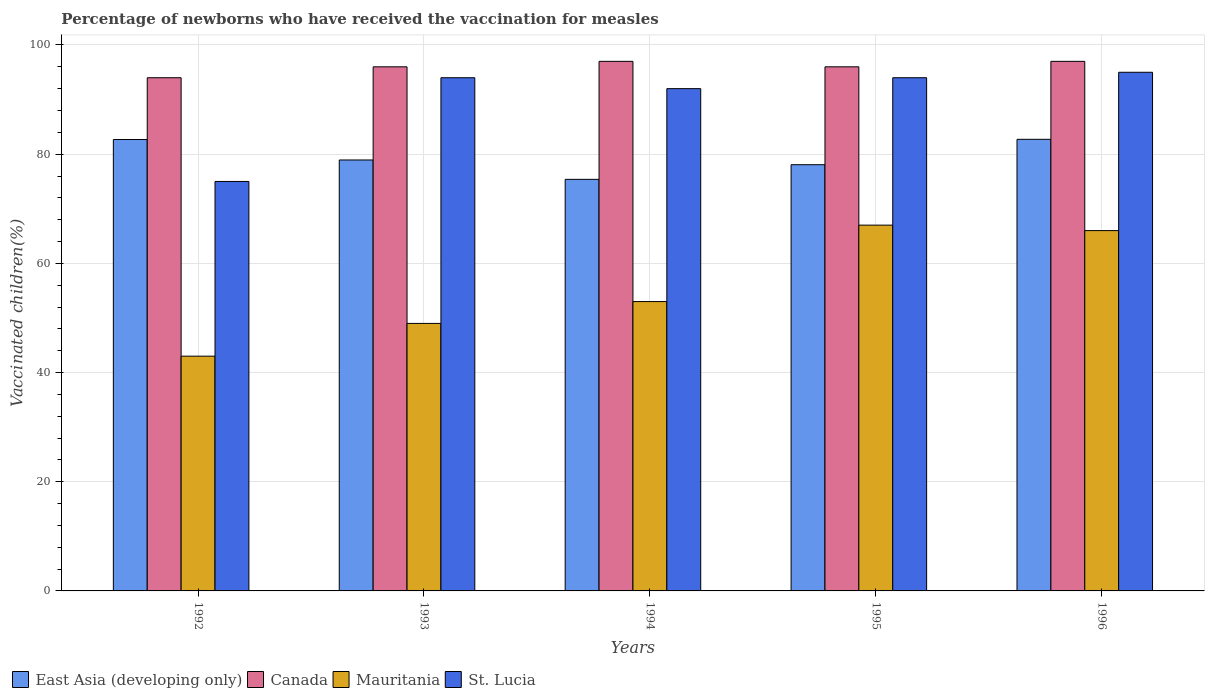How many different coloured bars are there?
Give a very brief answer. 4. Are the number of bars per tick equal to the number of legend labels?
Your answer should be very brief. Yes. How many bars are there on the 3rd tick from the left?
Provide a succinct answer. 4. How many bars are there on the 4th tick from the right?
Offer a terse response. 4. In how many cases, is the number of bars for a given year not equal to the number of legend labels?
Provide a short and direct response. 0. What is the percentage of vaccinated children in Canada in 1994?
Offer a very short reply. 97. Across all years, what is the maximum percentage of vaccinated children in East Asia (developing only)?
Your answer should be very brief. 82.72. In which year was the percentage of vaccinated children in Canada maximum?
Provide a short and direct response. 1994. What is the total percentage of vaccinated children in St. Lucia in the graph?
Offer a very short reply. 450. What is the difference between the percentage of vaccinated children in East Asia (developing only) in 1992 and the percentage of vaccinated children in Canada in 1996?
Provide a short and direct response. -14.31. What is the average percentage of vaccinated children in St. Lucia per year?
Your answer should be compact. 90. What is the ratio of the percentage of vaccinated children in Mauritania in 1992 to that in 1994?
Keep it short and to the point. 0.81. Is the percentage of vaccinated children in East Asia (developing only) in 1994 less than that in 1996?
Offer a terse response. Yes. What is the difference between the highest and the second highest percentage of vaccinated children in Canada?
Make the answer very short. 0. Is the sum of the percentage of vaccinated children in East Asia (developing only) in 1992 and 1994 greater than the maximum percentage of vaccinated children in Canada across all years?
Your answer should be compact. Yes. Is it the case that in every year, the sum of the percentage of vaccinated children in East Asia (developing only) and percentage of vaccinated children in St. Lucia is greater than the sum of percentage of vaccinated children in Canada and percentage of vaccinated children in Mauritania?
Provide a short and direct response. Yes. What does the 4th bar from the left in 1994 represents?
Ensure brevity in your answer.  St. Lucia. What does the 3rd bar from the right in 1992 represents?
Provide a short and direct response. Canada. Is it the case that in every year, the sum of the percentage of vaccinated children in Canada and percentage of vaccinated children in East Asia (developing only) is greater than the percentage of vaccinated children in St. Lucia?
Make the answer very short. Yes. How many bars are there?
Provide a short and direct response. 20. Are all the bars in the graph horizontal?
Keep it short and to the point. No. Are the values on the major ticks of Y-axis written in scientific E-notation?
Offer a very short reply. No. Does the graph contain any zero values?
Provide a succinct answer. No. Where does the legend appear in the graph?
Provide a succinct answer. Bottom left. How many legend labels are there?
Give a very brief answer. 4. What is the title of the graph?
Give a very brief answer. Percentage of newborns who have received the vaccination for measles. Does "Lesotho" appear as one of the legend labels in the graph?
Your answer should be compact. No. What is the label or title of the X-axis?
Your answer should be compact. Years. What is the label or title of the Y-axis?
Make the answer very short. Vaccinated children(%). What is the Vaccinated children(%) of East Asia (developing only) in 1992?
Your response must be concise. 82.69. What is the Vaccinated children(%) of Canada in 1992?
Ensure brevity in your answer.  94. What is the Vaccinated children(%) of Mauritania in 1992?
Offer a terse response. 43. What is the Vaccinated children(%) in East Asia (developing only) in 1993?
Offer a terse response. 78.94. What is the Vaccinated children(%) in Canada in 1993?
Offer a terse response. 96. What is the Vaccinated children(%) of Mauritania in 1993?
Provide a succinct answer. 49. What is the Vaccinated children(%) of St. Lucia in 1993?
Provide a short and direct response. 94. What is the Vaccinated children(%) in East Asia (developing only) in 1994?
Your answer should be very brief. 75.39. What is the Vaccinated children(%) of Canada in 1994?
Provide a short and direct response. 97. What is the Vaccinated children(%) in Mauritania in 1994?
Offer a very short reply. 53. What is the Vaccinated children(%) of St. Lucia in 1994?
Keep it short and to the point. 92. What is the Vaccinated children(%) in East Asia (developing only) in 1995?
Make the answer very short. 78.07. What is the Vaccinated children(%) in Canada in 1995?
Provide a short and direct response. 96. What is the Vaccinated children(%) of St. Lucia in 1995?
Your response must be concise. 94. What is the Vaccinated children(%) of East Asia (developing only) in 1996?
Offer a very short reply. 82.72. What is the Vaccinated children(%) of Canada in 1996?
Offer a terse response. 97. What is the Vaccinated children(%) in Mauritania in 1996?
Offer a terse response. 66. Across all years, what is the maximum Vaccinated children(%) of East Asia (developing only)?
Provide a succinct answer. 82.72. Across all years, what is the maximum Vaccinated children(%) in Canada?
Offer a terse response. 97. Across all years, what is the maximum Vaccinated children(%) in Mauritania?
Offer a very short reply. 67. Across all years, what is the minimum Vaccinated children(%) in East Asia (developing only)?
Make the answer very short. 75.39. Across all years, what is the minimum Vaccinated children(%) of Canada?
Your answer should be very brief. 94. Across all years, what is the minimum Vaccinated children(%) in St. Lucia?
Your response must be concise. 75. What is the total Vaccinated children(%) in East Asia (developing only) in the graph?
Your answer should be very brief. 397.8. What is the total Vaccinated children(%) in Canada in the graph?
Give a very brief answer. 480. What is the total Vaccinated children(%) of Mauritania in the graph?
Offer a terse response. 278. What is the total Vaccinated children(%) in St. Lucia in the graph?
Offer a very short reply. 450. What is the difference between the Vaccinated children(%) in East Asia (developing only) in 1992 and that in 1993?
Ensure brevity in your answer.  3.75. What is the difference between the Vaccinated children(%) of St. Lucia in 1992 and that in 1993?
Ensure brevity in your answer.  -19. What is the difference between the Vaccinated children(%) of East Asia (developing only) in 1992 and that in 1994?
Ensure brevity in your answer.  7.3. What is the difference between the Vaccinated children(%) of Canada in 1992 and that in 1994?
Offer a terse response. -3. What is the difference between the Vaccinated children(%) of Mauritania in 1992 and that in 1994?
Ensure brevity in your answer.  -10. What is the difference between the Vaccinated children(%) of St. Lucia in 1992 and that in 1994?
Provide a short and direct response. -17. What is the difference between the Vaccinated children(%) of East Asia (developing only) in 1992 and that in 1995?
Your response must be concise. 4.62. What is the difference between the Vaccinated children(%) of Canada in 1992 and that in 1995?
Your response must be concise. -2. What is the difference between the Vaccinated children(%) of St. Lucia in 1992 and that in 1995?
Provide a succinct answer. -19. What is the difference between the Vaccinated children(%) in East Asia (developing only) in 1992 and that in 1996?
Offer a very short reply. -0.03. What is the difference between the Vaccinated children(%) of Canada in 1992 and that in 1996?
Give a very brief answer. -3. What is the difference between the Vaccinated children(%) of Mauritania in 1992 and that in 1996?
Provide a short and direct response. -23. What is the difference between the Vaccinated children(%) of East Asia (developing only) in 1993 and that in 1994?
Your answer should be very brief. 3.55. What is the difference between the Vaccinated children(%) in Canada in 1993 and that in 1994?
Keep it short and to the point. -1. What is the difference between the Vaccinated children(%) in East Asia (developing only) in 1993 and that in 1995?
Provide a short and direct response. 0.87. What is the difference between the Vaccinated children(%) of St. Lucia in 1993 and that in 1995?
Provide a short and direct response. 0. What is the difference between the Vaccinated children(%) in East Asia (developing only) in 1993 and that in 1996?
Your response must be concise. -3.78. What is the difference between the Vaccinated children(%) in St. Lucia in 1993 and that in 1996?
Your answer should be compact. -1. What is the difference between the Vaccinated children(%) of East Asia (developing only) in 1994 and that in 1995?
Ensure brevity in your answer.  -2.68. What is the difference between the Vaccinated children(%) of Canada in 1994 and that in 1995?
Ensure brevity in your answer.  1. What is the difference between the Vaccinated children(%) of St. Lucia in 1994 and that in 1995?
Provide a short and direct response. -2. What is the difference between the Vaccinated children(%) of East Asia (developing only) in 1994 and that in 1996?
Offer a terse response. -7.33. What is the difference between the Vaccinated children(%) in Mauritania in 1994 and that in 1996?
Make the answer very short. -13. What is the difference between the Vaccinated children(%) in St. Lucia in 1994 and that in 1996?
Ensure brevity in your answer.  -3. What is the difference between the Vaccinated children(%) in East Asia (developing only) in 1995 and that in 1996?
Give a very brief answer. -4.65. What is the difference between the Vaccinated children(%) of Mauritania in 1995 and that in 1996?
Give a very brief answer. 1. What is the difference between the Vaccinated children(%) in St. Lucia in 1995 and that in 1996?
Give a very brief answer. -1. What is the difference between the Vaccinated children(%) of East Asia (developing only) in 1992 and the Vaccinated children(%) of Canada in 1993?
Offer a very short reply. -13.31. What is the difference between the Vaccinated children(%) in East Asia (developing only) in 1992 and the Vaccinated children(%) in Mauritania in 1993?
Offer a very short reply. 33.69. What is the difference between the Vaccinated children(%) of East Asia (developing only) in 1992 and the Vaccinated children(%) of St. Lucia in 1993?
Provide a succinct answer. -11.31. What is the difference between the Vaccinated children(%) of Mauritania in 1992 and the Vaccinated children(%) of St. Lucia in 1993?
Offer a very short reply. -51. What is the difference between the Vaccinated children(%) in East Asia (developing only) in 1992 and the Vaccinated children(%) in Canada in 1994?
Provide a succinct answer. -14.31. What is the difference between the Vaccinated children(%) in East Asia (developing only) in 1992 and the Vaccinated children(%) in Mauritania in 1994?
Your answer should be very brief. 29.69. What is the difference between the Vaccinated children(%) in East Asia (developing only) in 1992 and the Vaccinated children(%) in St. Lucia in 1994?
Offer a terse response. -9.31. What is the difference between the Vaccinated children(%) in Canada in 1992 and the Vaccinated children(%) in Mauritania in 1994?
Make the answer very short. 41. What is the difference between the Vaccinated children(%) in Mauritania in 1992 and the Vaccinated children(%) in St. Lucia in 1994?
Your response must be concise. -49. What is the difference between the Vaccinated children(%) in East Asia (developing only) in 1992 and the Vaccinated children(%) in Canada in 1995?
Provide a succinct answer. -13.31. What is the difference between the Vaccinated children(%) in East Asia (developing only) in 1992 and the Vaccinated children(%) in Mauritania in 1995?
Provide a succinct answer. 15.69. What is the difference between the Vaccinated children(%) of East Asia (developing only) in 1992 and the Vaccinated children(%) of St. Lucia in 1995?
Your answer should be very brief. -11.31. What is the difference between the Vaccinated children(%) in Canada in 1992 and the Vaccinated children(%) in Mauritania in 1995?
Provide a succinct answer. 27. What is the difference between the Vaccinated children(%) of Canada in 1992 and the Vaccinated children(%) of St. Lucia in 1995?
Give a very brief answer. 0. What is the difference between the Vaccinated children(%) of Mauritania in 1992 and the Vaccinated children(%) of St. Lucia in 1995?
Your answer should be compact. -51. What is the difference between the Vaccinated children(%) of East Asia (developing only) in 1992 and the Vaccinated children(%) of Canada in 1996?
Offer a terse response. -14.31. What is the difference between the Vaccinated children(%) of East Asia (developing only) in 1992 and the Vaccinated children(%) of Mauritania in 1996?
Offer a very short reply. 16.69. What is the difference between the Vaccinated children(%) in East Asia (developing only) in 1992 and the Vaccinated children(%) in St. Lucia in 1996?
Provide a succinct answer. -12.31. What is the difference between the Vaccinated children(%) in Mauritania in 1992 and the Vaccinated children(%) in St. Lucia in 1996?
Provide a succinct answer. -52. What is the difference between the Vaccinated children(%) in East Asia (developing only) in 1993 and the Vaccinated children(%) in Canada in 1994?
Provide a succinct answer. -18.06. What is the difference between the Vaccinated children(%) of East Asia (developing only) in 1993 and the Vaccinated children(%) of Mauritania in 1994?
Offer a terse response. 25.94. What is the difference between the Vaccinated children(%) of East Asia (developing only) in 1993 and the Vaccinated children(%) of St. Lucia in 1994?
Your response must be concise. -13.06. What is the difference between the Vaccinated children(%) of Mauritania in 1993 and the Vaccinated children(%) of St. Lucia in 1994?
Your answer should be very brief. -43. What is the difference between the Vaccinated children(%) of East Asia (developing only) in 1993 and the Vaccinated children(%) of Canada in 1995?
Give a very brief answer. -17.06. What is the difference between the Vaccinated children(%) in East Asia (developing only) in 1993 and the Vaccinated children(%) in Mauritania in 1995?
Keep it short and to the point. 11.94. What is the difference between the Vaccinated children(%) of East Asia (developing only) in 1993 and the Vaccinated children(%) of St. Lucia in 1995?
Keep it short and to the point. -15.06. What is the difference between the Vaccinated children(%) of Canada in 1993 and the Vaccinated children(%) of Mauritania in 1995?
Your response must be concise. 29. What is the difference between the Vaccinated children(%) in Canada in 1993 and the Vaccinated children(%) in St. Lucia in 1995?
Offer a terse response. 2. What is the difference between the Vaccinated children(%) of Mauritania in 1993 and the Vaccinated children(%) of St. Lucia in 1995?
Keep it short and to the point. -45. What is the difference between the Vaccinated children(%) in East Asia (developing only) in 1993 and the Vaccinated children(%) in Canada in 1996?
Provide a succinct answer. -18.06. What is the difference between the Vaccinated children(%) in East Asia (developing only) in 1993 and the Vaccinated children(%) in Mauritania in 1996?
Your answer should be very brief. 12.94. What is the difference between the Vaccinated children(%) of East Asia (developing only) in 1993 and the Vaccinated children(%) of St. Lucia in 1996?
Keep it short and to the point. -16.06. What is the difference between the Vaccinated children(%) of Canada in 1993 and the Vaccinated children(%) of St. Lucia in 1996?
Your response must be concise. 1. What is the difference between the Vaccinated children(%) of Mauritania in 1993 and the Vaccinated children(%) of St. Lucia in 1996?
Offer a very short reply. -46. What is the difference between the Vaccinated children(%) of East Asia (developing only) in 1994 and the Vaccinated children(%) of Canada in 1995?
Provide a succinct answer. -20.61. What is the difference between the Vaccinated children(%) of East Asia (developing only) in 1994 and the Vaccinated children(%) of Mauritania in 1995?
Give a very brief answer. 8.39. What is the difference between the Vaccinated children(%) in East Asia (developing only) in 1994 and the Vaccinated children(%) in St. Lucia in 1995?
Make the answer very short. -18.61. What is the difference between the Vaccinated children(%) in Canada in 1994 and the Vaccinated children(%) in St. Lucia in 1995?
Your response must be concise. 3. What is the difference between the Vaccinated children(%) in Mauritania in 1994 and the Vaccinated children(%) in St. Lucia in 1995?
Ensure brevity in your answer.  -41. What is the difference between the Vaccinated children(%) in East Asia (developing only) in 1994 and the Vaccinated children(%) in Canada in 1996?
Make the answer very short. -21.61. What is the difference between the Vaccinated children(%) of East Asia (developing only) in 1994 and the Vaccinated children(%) of Mauritania in 1996?
Offer a very short reply. 9.39. What is the difference between the Vaccinated children(%) of East Asia (developing only) in 1994 and the Vaccinated children(%) of St. Lucia in 1996?
Give a very brief answer. -19.61. What is the difference between the Vaccinated children(%) of Canada in 1994 and the Vaccinated children(%) of St. Lucia in 1996?
Your answer should be compact. 2. What is the difference between the Vaccinated children(%) in Mauritania in 1994 and the Vaccinated children(%) in St. Lucia in 1996?
Offer a very short reply. -42. What is the difference between the Vaccinated children(%) in East Asia (developing only) in 1995 and the Vaccinated children(%) in Canada in 1996?
Your answer should be compact. -18.93. What is the difference between the Vaccinated children(%) in East Asia (developing only) in 1995 and the Vaccinated children(%) in Mauritania in 1996?
Ensure brevity in your answer.  12.07. What is the difference between the Vaccinated children(%) of East Asia (developing only) in 1995 and the Vaccinated children(%) of St. Lucia in 1996?
Provide a short and direct response. -16.93. What is the difference between the Vaccinated children(%) of Canada in 1995 and the Vaccinated children(%) of St. Lucia in 1996?
Your answer should be very brief. 1. What is the difference between the Vaccinated children(%) in Mauritania in 1995 and the Vaccinated children(%) in St. Lucia in 1996?
Ensure brevity in your answer.  -28. What is the average Vaccinated children(%) in East Asia (developing only) per year?
Give a very brief answer. 79.56. What is the average Vaccinated children(%) of Canada per year?
Your response must be concise. 96. What is the average Vaccinated children(%) of Mauritania per year?
Your answer should be compact. 55.6. In the year 1992, what is the difference between the Vaccinated children(%) in East Asia (developing only) and Vaccinated children(%) in Canada?
Provide a succinct answer. -11.31. In the year 1992, what is the difference between the Vaccinated children(%) of East Asia (developing only) and Vaccinated children(%) of Mauritania?
Provide a succinct answer. 39.69. In the year 1992, what is the difference between the Vaccinated children(%) in East Asia (developing only) and Vaccinated children(%) in St. Lucia?
Provide a short and direct response. 7.69. In the year 1992, what is the difference between the Vaccinated children(%) in Mauritania and Vaccinated children(%) in St. Lucia?
Your response must be concise. -32. In the year 1993, what is the difference between the Vaccinated children(%) of East Asia (developing only) and Vaccinated children(%) of Canada?
Make the answer very short. -17.06. In the year 1993, what is the difference between the Vaccinated children(%) of East Asia (developing only) and Vaccinated children(%) of Mauritania?
Offer a terse response. 29.94. In the year 1993, what is the difference between the Vaccinated children(%) of East Asia (developing only) and Vaccinated children(%) of St. Lucia?
Ensure brevity in your answer.  -15.06. In the year 1993, what is the difference between the Vaccinated children(%) of Canada and Vaccinated children(%) of Mauritania?
Your answer should be compact. 47. In the year 1993, what is the difference between the Vaccinated children(%) of Canada and Vaccinated children(%) of St. Lucia?
Your answer should be compact. 2. In the year 1993, what is the difference between the Vaccinated children(%) of Mauritania and Vaccinated children(%) of St. Lucia?
Your response must be concise. -45. In the year 1994, what is the difference between the Vaccinated children(%) in East Asia (developing only) and Vaccinated children(%) in Canada?
Provide a succinct answer. -21.61. In the year 1994, what is the difference between the Vaccinated children(%) in East Asia (developing only) and Vaccinated children(%) in Mauritania?
Make the answer very short. 22.39. In the year 1994, what is the difference between the Vaccinated children(%) of East Asia (developing only) and Vaccinated children(%) of St. Lucia?
Make the answer very short. -16.61. In the year 1994, what is the difference between the Vaccinated children(%) in Canada and Vaccinated children(%) in Mauritania?
Offer a very short reply. 44. In the year 1994, what is the difference between the Vaccinated children(%) of Mauritania and Vaccinated children(%) of St. Lucia?
Make the answer very short. -39. In the year 1995, what is the difference between the Vaccinated children(%) of East Asia (developing only) and Vaccinated children(%) of Canada?
Give a very brief answer. -17.93. In the year 1995, what is the difference between the Vaccinated children(%) of East Asia (developing only) and Vaccinated children(%) of Mauritania?
Your answer should be compact. 11.07. In the year 1995, what is the difference between the Vaccinated children(%) of East Asia (developing only) and Vaccinated children(%) of St. Lucia?
Offer a very short reply. -15.93. In the year 1995, what is the difference between the Vaccinated children(%) of Canada and Vaccinated children(%) of Mauritania?
Ensure brevity in your answer.  29. In the year 1995, what is the difference between the Vaccinated children(%) of Canada and Vaccinated children(%) of St. Lucia?
Ensure brevity in your answer.  2. In the year 1995, what is the difference between the Vaccinated children(%) in Mauritania and Vaccinated children(%) in St. Lucia?
Give a very brief answer. -27. In the year 1996, what is the difference between the Vaccinated children(%) in East Asia (developing only) and Vaccinated children(%) in Canada?
Provide a short and direct response. -14.28. In the year 1996, what is the difference between the Vaccinated children(%) in East Asia (developing only) and Vaccinated children(%) in Mauritania?
Ensure brevity in your answer.  16.72. In the year 1996, what is the difference between the Vaccinated children(%) in East Asia (developing only) and Vaccinated children(%) in St. Lucia?
Your response must be concise. -12.28. In the year 1996, what is the difference between the Vaccinated children(%) of Canada and Vaccinated children(%) of Mauritania?
Your answer should be compact. 31. In the year 1996, what is the difference between the Vaccinated children(%) in Canada and Vaccinated children(%) in St. Lucia?
Your answer should be very brief. 2. In the year 1996, what is the difference between the Vaccinated children(%) of Mauritania and Vaccinated children(%) of St. Lucia?
Make the answer very short. -29. What is the ratio of the Vaccinated children(%) of East Asia (developing only) in 1992 to that in 1993?
Provide a succinct answer. 1.05. What is the ratio of the Vaccinated children(%) of Canada in 1992 to that in 1993?
Make the answer very short. 0.98. What is the ratio of the Vaccinated children(%) of Mauritania in 1992 to that in 1993?
Your answer should be compact. 0.88. What is the ratio of the Vaccinated children(%) in St. Lucia in 1992 to that in 1993?
Give a very brief answer. 0.8. What is the ratio of the Vaccinated children(%) in East Asia (developing only) in 1992 to that in 1994?
Give a very brief answer. 1.1. What is the ratio of the Vaccinated children(%) of Canada in 1992 to that in 1994?
Offer a terse response. 0.97. What is the ratio of the Vaccinated children(%) in Mauritania in 1992 to that in 1994?
Your answer should be very brief. 0.81. What is the ratio of the Vaccinated children(%) of St. Lucia in 1992 to that in 1994?
Offer a terse response. 0.82. What is the ratio of the Vaccinated children(%) of East Asia (developing only) in 1992 to that in 1995?
Give a very brief answer. 1.06. What is the ratio of the Vaccinated children(%) of Canada in 1992 to that in 1995?
Keep it short and to the point. 0.98. What is the ratio of the Vaccinated children(%) of Mauritania in 1992 to that in 1995?
Provide a succinct answer. 0.64. What is the ratio of the Vaccinated children(%) of St. Lucia in 1992 to that in 1995?
Give a very brief answer. 0.8. What is the ratio of the Vaccinated children(%) in Canada in 1992 to that in 1996?
Your answer should be compact. 0.97. What is the ratio of the Vaccinated children(%) of Mauritania in 1992 to that in 1996?
Ensure brevity in your answer.  0.65. What is the ratio of the Vaccinated children(%) of St. Lucia in 1992 to that in 1996?
Provide a succinct answer. 0.79. What is the ratio of the Vaccinated children(%) in East Asia (developing only) in 1993 to that in 1994?
Make the answer very short. 1.05. What is the ratio of the Vaccinated children(%) in Canada in 1993 to that in 1994?
Ensure brevity in your answer.  0.99. What is the ratio of the Vaccinated children(%) in Mauritania in 1993 to that in 1994?
Your answer should be compact. 0.92. What is the ratio of the Vaccinated children(%) in St. Lucia in 1993 to that in 1994?
Offer a very short reply. 1.02. What is the ratio of the Vaccinated children(%) of East Asia (developing only) in 1993 to that in 1995?
Provide a short and direct response. 1.01. What is the ratio of the Vaccinated children(%) of Mauritania in 1993 to that in 1995?
Give a very brief answer. 0.73. What is the ratio of the Vaccinated children(%) of St. Lucia in 1993 to that in 1995?
Your answer should be very brief. 1. What is the ratio of the Vaccinated children(%) in East Asia (developing only) in 1993 to that in 1996?
Provide a short and direct response. 0.95. What is the ratio of the Vaccinated children(%) in Mauritania in 1993 to that in 1996?
Make the answer very short. 0.74. What is the ratio of the Vaccinated children(%) of St. Lucia in 1993 to that in 1996?
Your answer should be compact. 0.99. What is the ratio of the Vaccinated children(%) in East Asia (developing only) in 1994 to that in 1995?
Make the answer very short. 0.97. What is the ratio of the Vaccinated children(%) of Canada in 1994 to that in 1995?
Offer a very short reply. 1.01. What is the ratio of the Vaccinated children(%) in Mauritania in 1994 to that in 1995?
Offer a terse response. 0.79. What is the ratio of the Vaccinated children(%) in St. Lucia in 1994 to that in 1995?
Ensure brevity in your answer.  0.98. What is the ratio of the Vaccinated children(%) in East Asia (developing only) in 1994 to that in 1996?
Provide a succinct answer. 0.91. What is the ratio of the Vaccinated children(%) of Mauritania in 1994 to that in 1996?
Give a very brief answer. 0.8. What is the ratio of the Vaccinated children(%) of St. Lucia in 1994 to that in 1996?
Offer a very short reply. 0.97. What is the ratio of the Vaccinated children(%) in East Asia (developing only) in 1995 to that in 1996?
Your answer should be very brief. 0.94. What is the ratio of the Vaccinated children(%) of Mauritania in 1995 to that in 1996?
Provide a succinct answer. 1.02. What is the ratio of the Vaccinated children(%) of St. Lucia in 1995 to that in 1996?
Your answer should be very brief. 0.99. What is the difference between the highest and the second highest Vaccinated children(%) of East Asia (developing only)?
Make the answer very short. 0.03. What is the difference between the highest and the second highest Vaccinated children(%) of Mauritania?
Your answer should be compact. 1. What is the difference between the highest and the second highest Vaccinated children(%) of St. Lucia?
Offer a very short reply. 1. What is the difference between the highest and the lowest Vaccinated children(%) in East Asia (developing only)?
Provide a short and direct response. 7.33. What is the difference between the highest and the lowest Vaccinated children(%) in Canada?
Make the answer very short. 3. What is the difference between the highest and the lowest Vaccinated children(%) of Mauritania?
Your response must be concise. 24. 